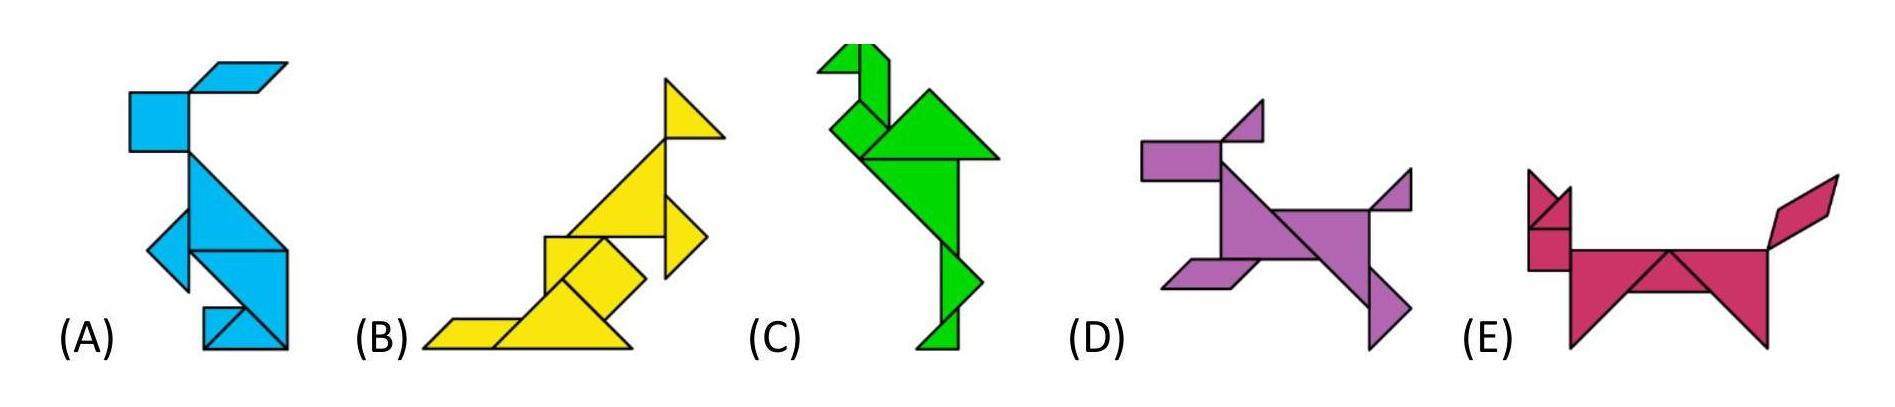These five animals are made up from different shapes. There is one shape which is only used on one animal. On which animal is this shape used?
Choices: ['A', 'B', 'C', 'D', 'E'] The unique shape in question can be located on the depiction of animal D. This particular animal is distinguished by a distinctive pair of triangular shapes that resemble ears, placed atop its head. These shapes are notable for not being replicated on any of the other geometric animals presented. Thereby, animal D is the correct answer as it is the only one featuring this exclusive geometric configuration. 